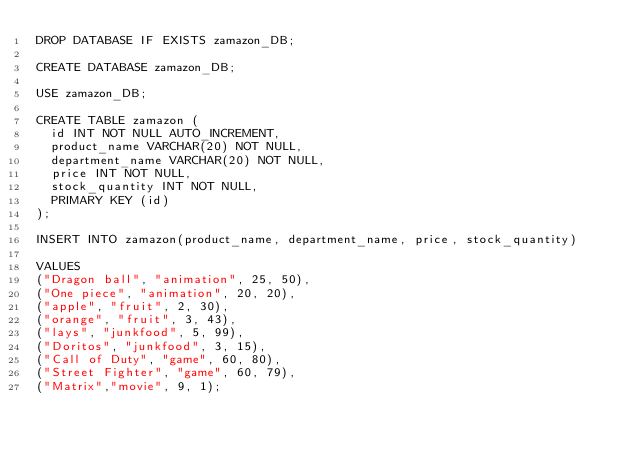<code> <loc_0><loc_0><loc_500><loc_500><_SQL_>DROP DATABASE IF EXISTS zamazon_DB;

CREATE DATABASE zamazon_DB;

USE zamazon_DB;

CREATE TABLE zamazon (
  id INT NOT NULL AUTO_INCREMENT,
  product_name VARCHAR(20) NOT NULL,
  department_name VARCHAR(20) NOT NULL,
  price INT NOT NULL,
  stock_quantity INT NOT NULL,
  PRIMARY KEY (id)
);

INSERT INTO zamazon(product_name, department_name, price, stock_quantity)

VALUES
("Dragon ball", "animation", 25, 50),
("One piece", "animation", 20, 20),
("apple", "fruit", 2, 30),
("orange", "fruit", 3, 43),
("lays", "junkfood", 5, 99),
("Doritos", "junkfood", 3, 15),
("Call of Duty", "game", 60, 80),
("Street Fighter", "game", 60, 79),
("Matrix","movie", 9, 1);</code> 